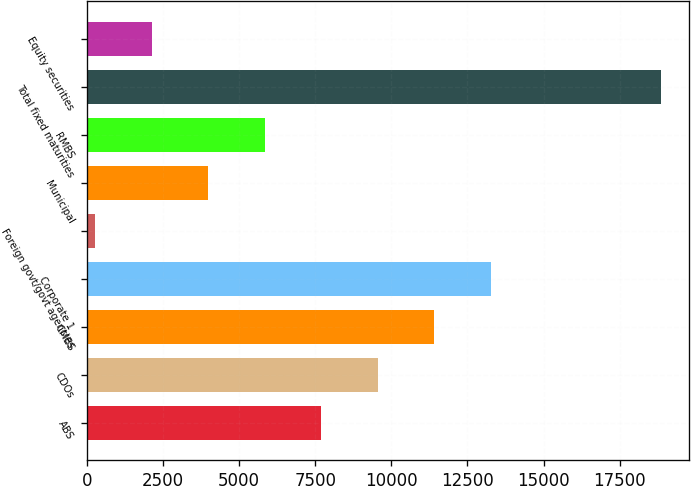<chart> <loc_0><loc_0><loc_500><loc_500><bar_chart><fcel>ABS<fcel>CDOs<fcel>CMBS<fcel>Corporate 1<fcel>Foreign govt/govt agencies<fcel>Municipal<fcel>RMBS<fcel>Total fixed maturities<fcel>Equity securities<nl><fcel>7699<fcel>9556.5<fcel>11414<fcel>13271.5<fcel>269<fcel>3984<fcel>5841.5<fcel>18844<fcel>2126.5<nl></chart> 